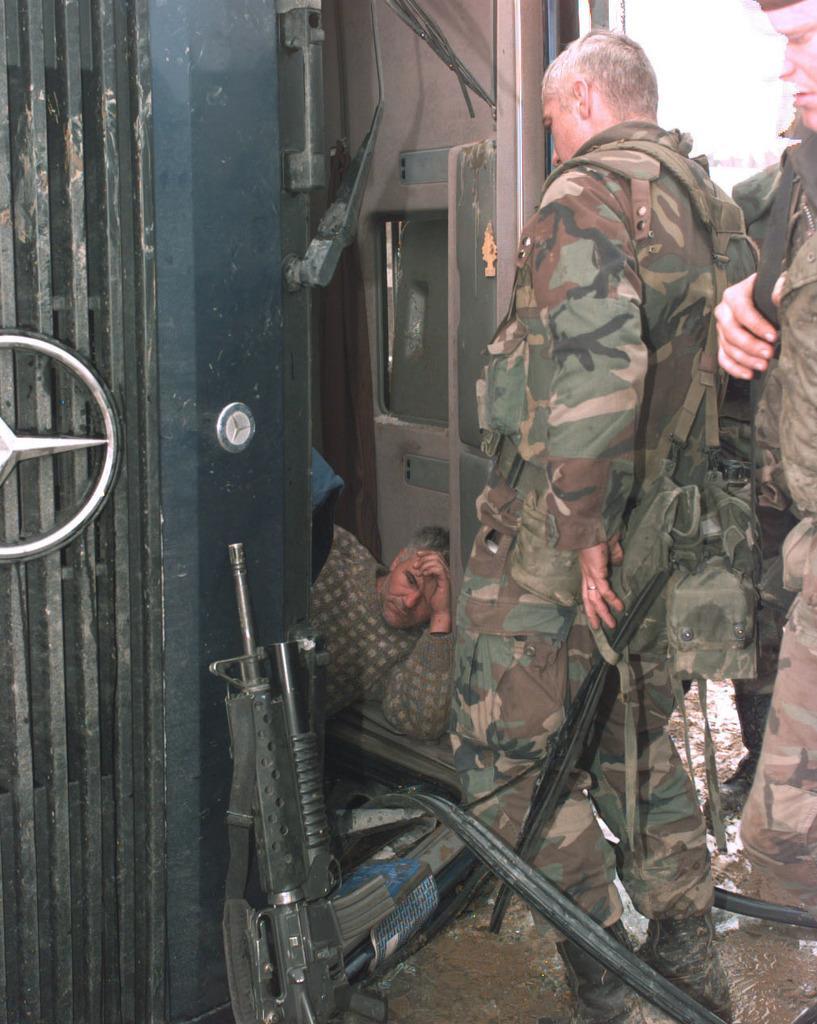Describe this image in one or two sentences. In this image in the foreground there are a group of people who are standing and one person is lying and he is in some house. At the bottom there are some guns, and in the background there is sky. 